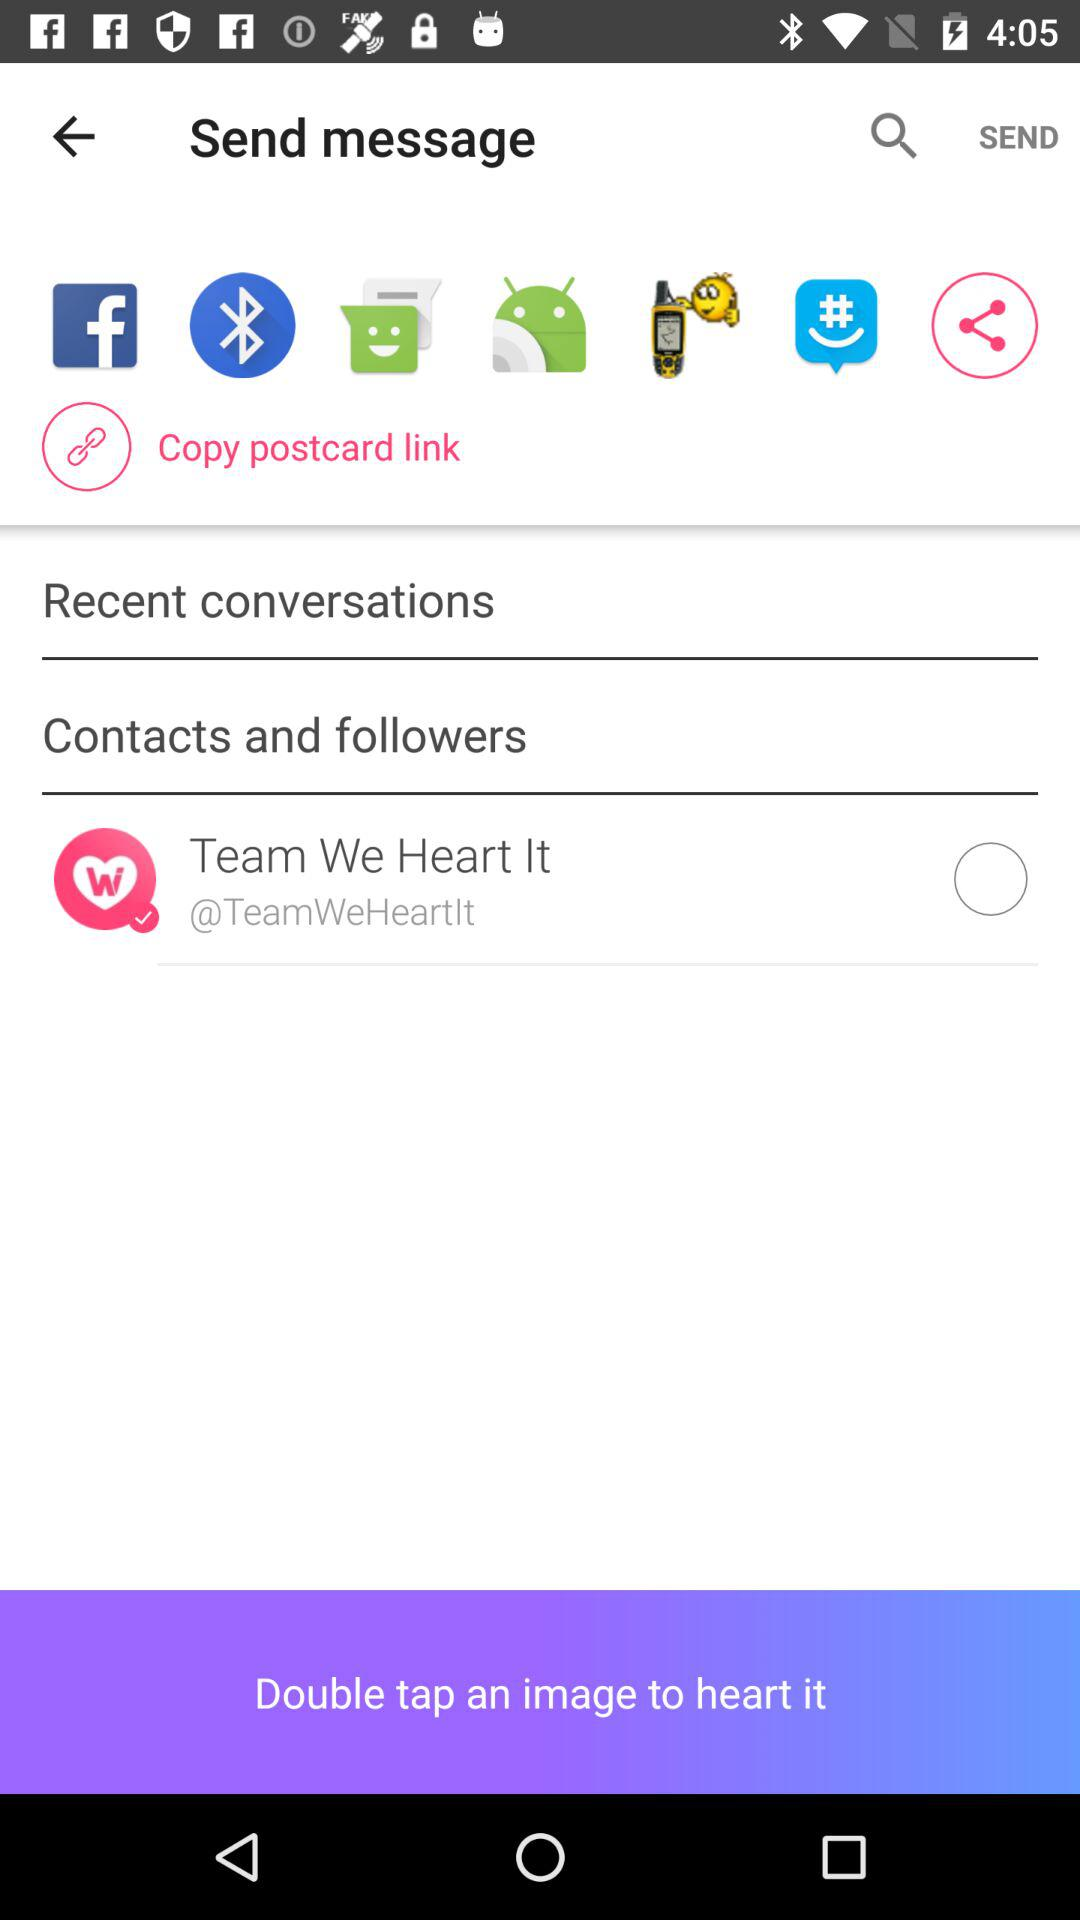What are the options available for sharing? The available options for sharing are "Facebook", "Bluetooth", "Messaging", "Android Beam", "Fake GPS - Search location" and "GroupMe". 